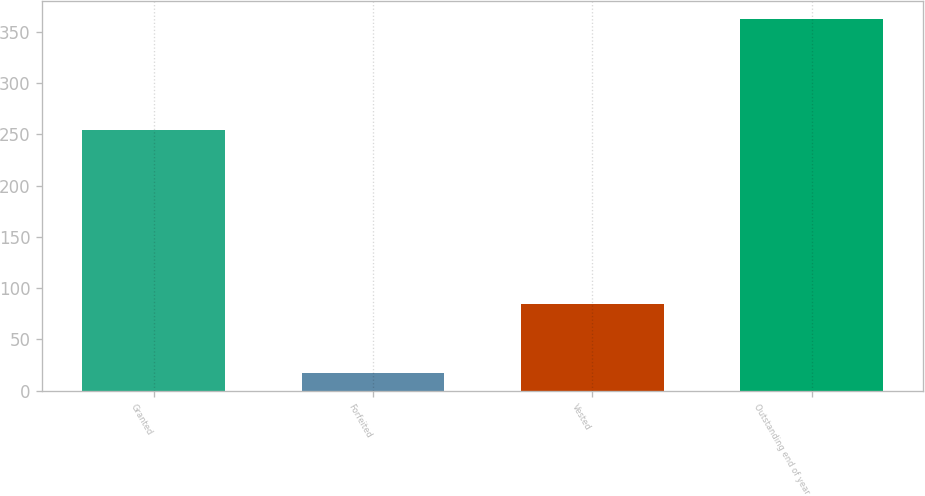<chart> <loc_0><loc_0><loc_500><loc_500><bar_chart><fcel>Granted<fcel>Forfeited<fcel>Vested<fcel>Outstanding end of year<nl><fcel>254<fcel>17<fcel>85<fcel>362<nl></chart> 